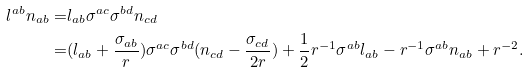Convert formula to latex. <formula><loc_0><loc_0><loc_500><loc_500>l ^ { a b } n _ { a b } = & l _ { a b } \sigma ^ { a c } \sigma ^ { b d } n _ { c d } \\ = & ( l _ { a b } + \frac { \sigma _ { a b } } { r } ) \sigma ^ { a c } \sigma ^ { b d } ( n _ { c d } - \frac { \sigma _ { c d } } { 2 r } ) + \frac { 1 } { 2 } r ^ { - 1 } \sigma ^ { a b } l _ { a b } - r ^ { - 1 } \sigma ^ { a b } n _ { a b } + r ^ { - 2 } . \\</formula> 